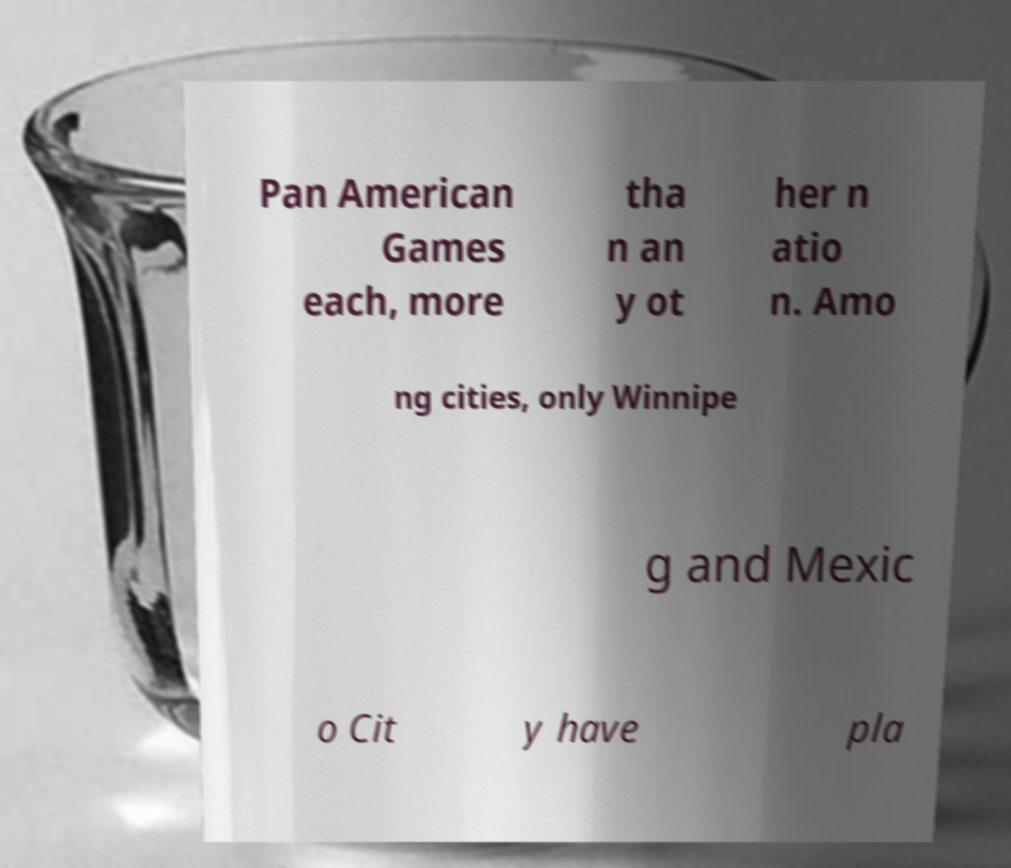There's text embedded in this image that I need extracted. Can you transcribe it verbatim? Pan American Games each, more tha n an y ot her n atio n. Amo ng cities, only Winnipe g and Mexic o Cit y have pla 